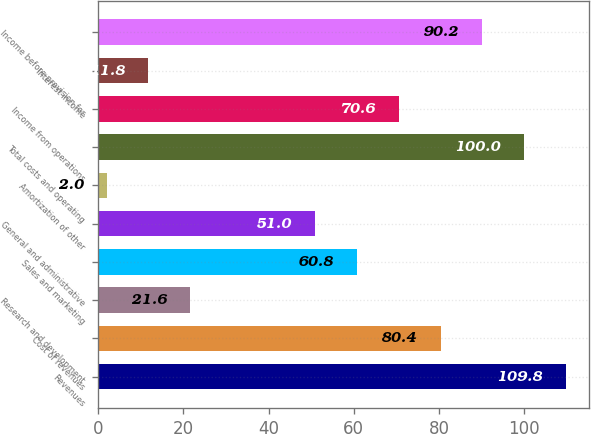Convert chart to OTSL. <chart><loc_0><loc_0><loc_500><loc_500><bar_chart><fcel>Revenues<fcel>Cost of revenues<fcel>Research and development<fcel>Sales and marketing<fcel>General and administrative<fcel>Amortization of other<fcel>Total costs and operating<fcel>Income from operations<fcel>Interest income<fcel>Income before provision for<nl><fcel>109.8<fcel>80.4<fcel>21.6<fcel>60.8<fcel>51<fcel>2<fcel>100<fcel>70.6<fcel>11.8<fcel>90.2<nl></chart> 